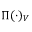<formula> <loc_0><loc_0><loc_500><loc_500>\Pi ( \cdot ) _ { V }</formula> 